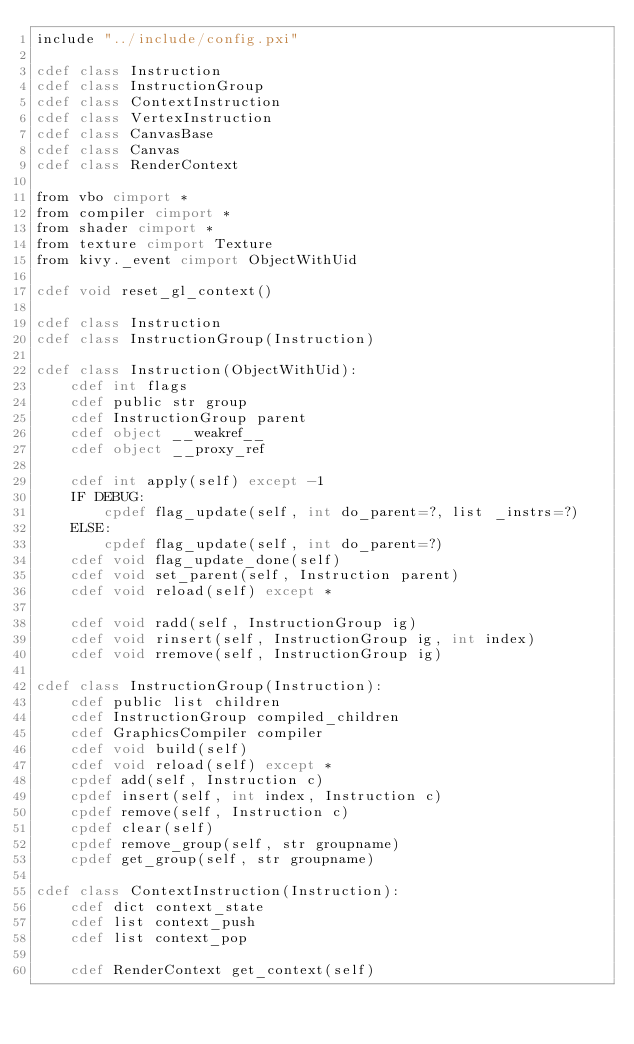<code> <loc_0><loc_0><loc_500><loc_500><_Cython_>include "../include/config.pxi"

cdef class Instruction
cdef class InstructionGroup
cdef class ContextInstruction
cdef class VertexInstruction
cdef class CanvasBase
cdef class Canvas
cdef class RenderContext

from vbo cimport *
from compiler cimport *
from shader cimport *
from texture cimport Texture
from kivy._event cimport ObjectWithUid

cdef void reset_gl_context()

cdef class Instruction
cdef class InstructionGroup(Instruction)

cdef class Instruction(ObjectWithUid):
    cdef int flags
    cdef public str group
    cdef InstructionGroup parent
    cdef object __weakref__
    cdef object __proxy_ref

    cdef int apply(self) except -1
    IF DEBUG:
        cpdef flag_update(self, int do_parent=?, list _instrs=?)
    ELSE:
        cpdef flag_update(self, int do_parent=?)
    cdef void flag_update_done(self)
    cdef void set_parent(self, Instruction parent)
    cdef void reload(self) except *

    cdef void radd(self, InstructionGroup ig)
    cdef void rinsert(self, InstructionGroup ig, int index)
    cdef void rremove(self, InstructionGroup ig)

cdef class InstructionGroup(Instruction):
    cdef public list children
    cdef InstructionGroup compiled_children
    cdef GraphicsCompiler compiler
    cdef void build(self)
    cdef void reload(self) except *
    cpdef add(self, Instruction c)
    cpdef insert(self, int index, Instruction c)
    cpdef remove(self, Instruction c)
    cpdef clear(self)
    cpdef remove_group(self, str groupname)
    cpdef get_group(self, str groupname)

cdef class ContextInstruction(Instruction):
    cdef dict context_state
    cdef list context_push
    cdef list context_pop

    cdef RenderContext get_context(self)</code> 